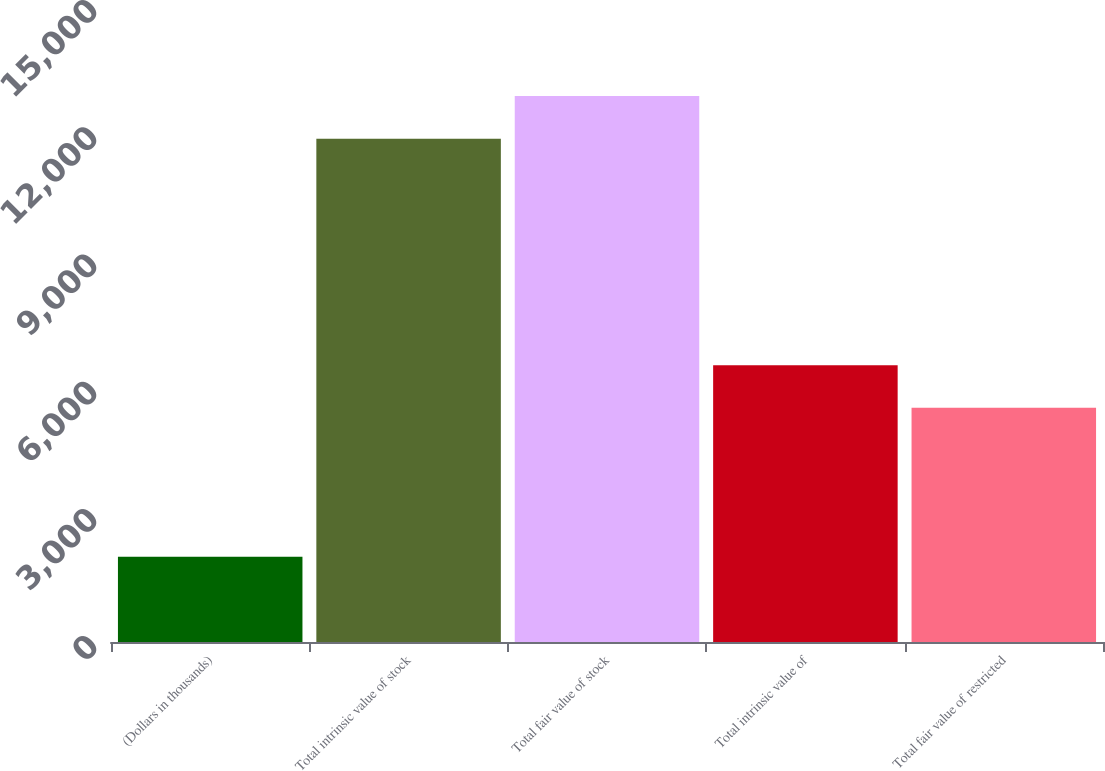Convert chart to OTSL. <chart><loc_0><loc_0><loc_500><loc_500><bar_chart><fcel>(Dollars in thousands)<fcel>Total intrinsic value of stock<fcel>Total fair value of stock<fcel>Total intrinsic value of<fcel>Total fair value of restricted<nl><fcel>2010<fcel>11871<fcel>12878.6<fcel>6529.6<fcel>5522<nl></chart> 